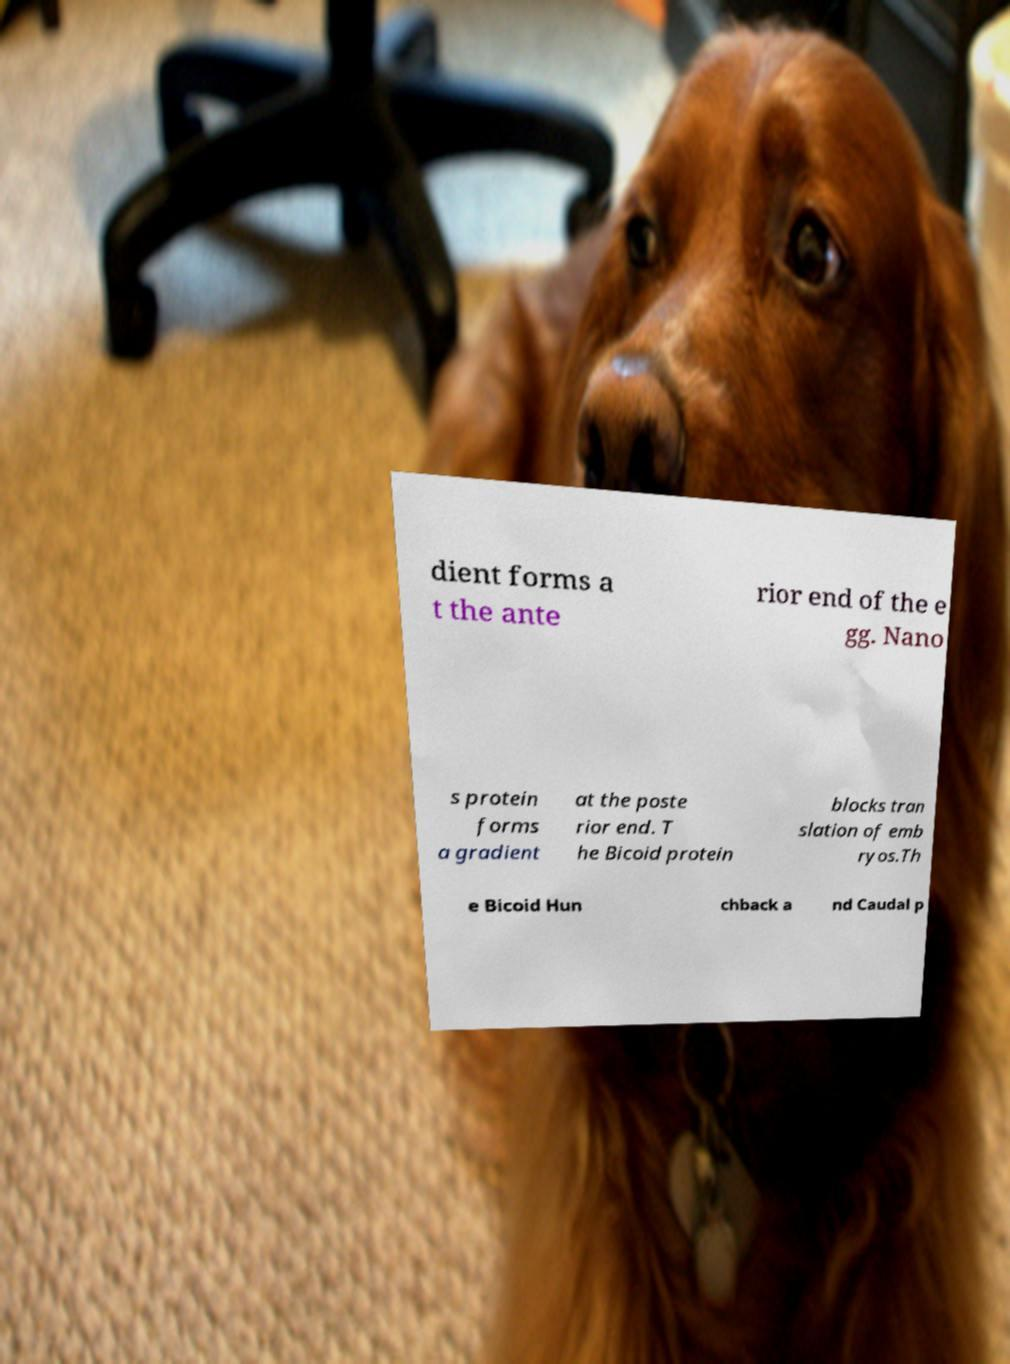Can you accurately transcribe the text from the provided image for me? dient forms a t the ante rior end of the e gg. Nano s protein forms a gradient at the poste rior end. T he Bicoid protein blocks tran slation of emb ryos.Th e Bicoid Hun chback a nd Caudal p 